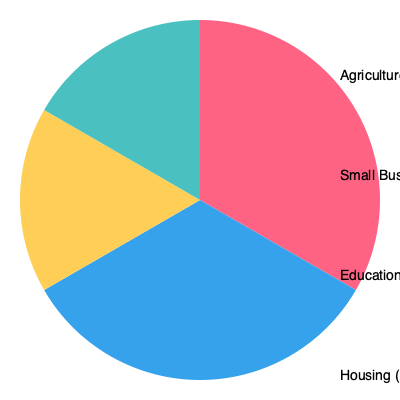Based on the pie chart showing the distribution of microfinance loans across different sectors, which sector receives the largest share of loans, and what percentage of total loans does it represent? To answer this question, we need to analyze the pie chart and follow these steps:

1. Identify all sectors represented in the pie chart:
   - Agriculture
   - Small Business
   - Education
   - Housing

2. Compare the sizes of the pie slices:
   - Agriculture: largest slice
   - Small Business: second largest
   - Education: third largest
   - Housing: smallest slice

3. Look at the percentages provided for each sector:
   - Agriculture: 40%
   - Small Business: 30%
   - Education: 20%
   - Housing: 10%

4. Determine the largest sector:
   Agriculture has the largest slice and the highest percentage (40%).

5. Confirm the percentage for the largest sector:
   The question asks for the percentage of total loans, which is 40% for Agriculture.
Answer: Agriculture, 40% 